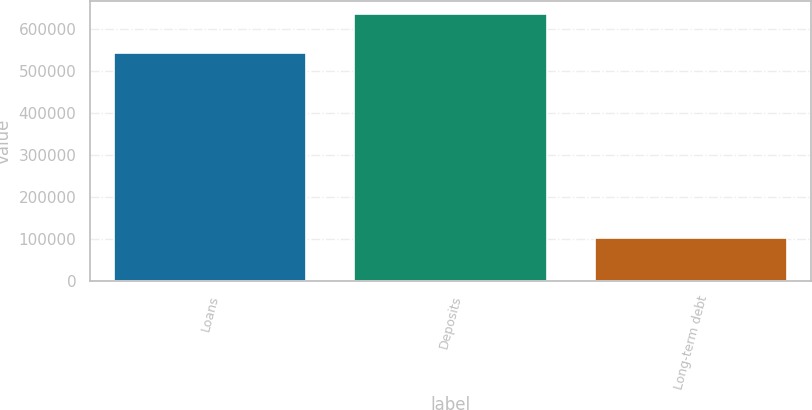Convert chart. <chart><loc_0><loc_0><loc_500><loc_500><bar_chart><fcel>Loans<fcel>Deposits<fcel>Long-term debt<nl><fcel>542626<fcel>633928<fcel>101446<nl></chart> 